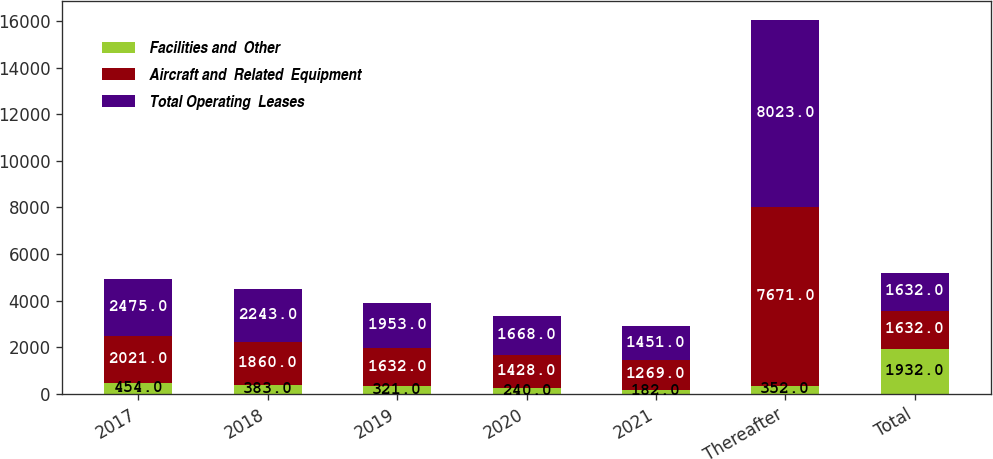Convert chart. <chart><loc_0><loc_0><loc_500><loc_500><stacked_bar_chart><ecel><fcel>2017<fcel>2018<fcel>2019<fcel>2020<fcel>2021<fcel>Thereafter<fcel>Total<nl><fcel>Facilities and  Other<fcel>454<fcel>383<fcel>321<fcel>240<fcel>182<fcel>352<fcel>1932<nl><fcel>Aircraft and  Related  Equipment<fcel>2021<fcel>1860<fcel>1632<fcel>1428<fcel>1269<fcel>7671<fcel>1632<nl><fcel>Total Operating  Leases<fcel>2475<fcel>2243<fcel>1953<fcel>1668<fcel>1451<fcel>8023<fcel>1632<nl></chart> 